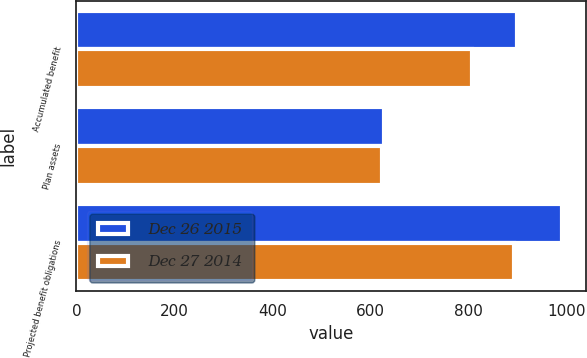Convert chart. <chart><loc_0><loc_0><loc_500><loc_500><stacked_bar_chart><ecel><fcel>Accumulated benefit<fcel>Plan assets<fcel>Projected benefit obligations<nl><fcel>Dec 26 2015<fcel>899<fcel>627<fcel>990<nl><fcel>Dec 27 2014<fcel>808<fcel>623<fcel>892<nl></chart> 